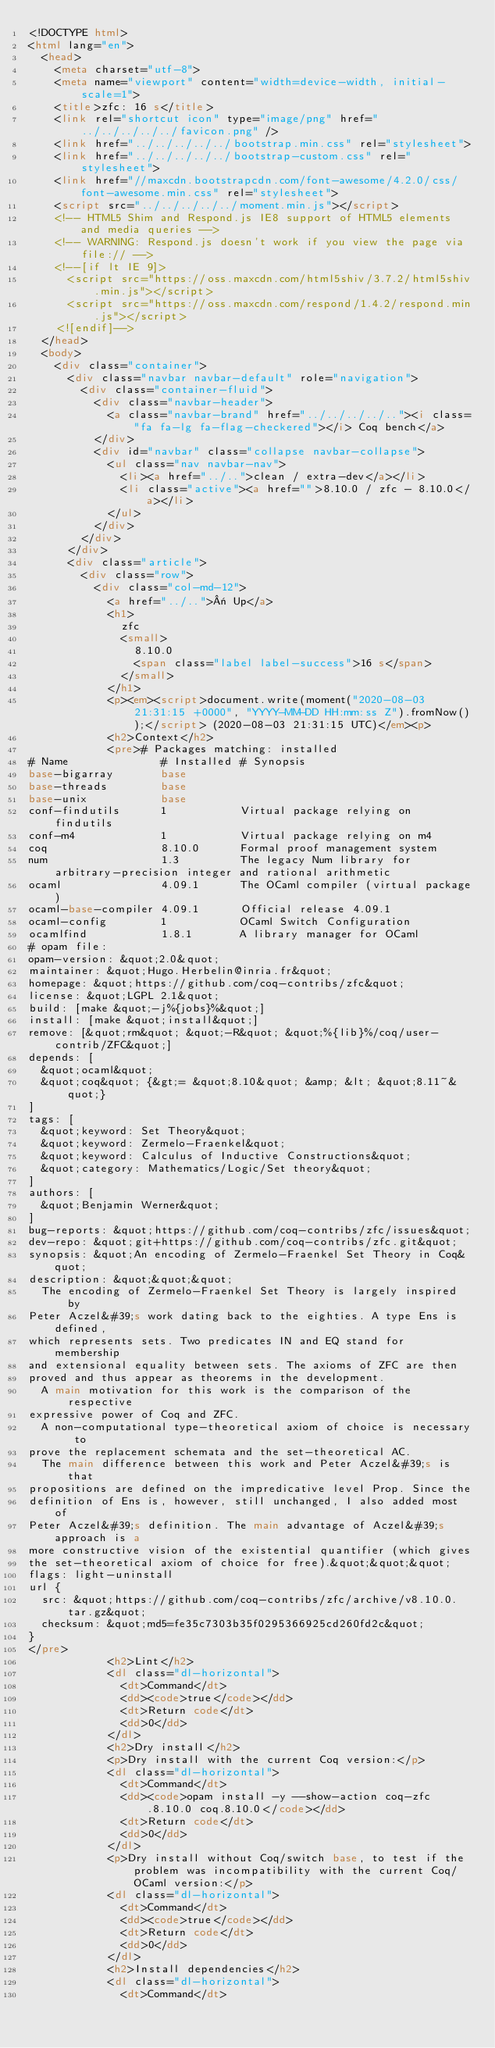Convert code to text. <code><loc_0><loc_0><loc_500><loc_500><_HTML_><!DOCTYPE html>
<html lang="en">
  <head>
    <meta charset="utf-8">
    <meta name="viewport" content="width=device-width, initial-scale=1">
    <title>zfc: 16 s</title>
    <link rel="shortcut icon" type="image/png" href="../../../../../favicon.png" />
    <link href="../../../../../bootstrap.min.css" rel="stylesheet">
    <link href="../../../../../bootstrap-custom.css" rel="stylesheet">
    <link href="//maxcdn.bootstrapcdn.com/font-awesome/4.2.0/css/font-awesome.min.css" rel="stylesheet">
    <script src="../../../../../moment.min.js"></script>
    <!-- HTML5 Shim and Respond.js IE8 support of HTML5 elements and media queries -->
    <!-- WARNING: Respond.js doesn't work if you view the page via file:// -->
    <!--[if lt IE 9]>
      <script src="https://oss.maxcdn.com/html5shiv/3.7.2/html5shiv.min.js"></script>
      <script src="https://oss.maxcdn.com/respond/1.4.2/respond.min.js"></script>
    <![endif]-->
  </head>
  <body>
    <div class="container">
      <div class="navbar navbar-default" role="navigation">
        <div class="container-fluid">
          <div class="navbar-header">
            <a class="navbar-brand" href="../../../../.."><i class="fa fa-lg fa-flag-checkered"></i> Coq bench</a>
          </div>
          <div id="navbar" class="collapse navbar-collapse">
            <ul class="nav navbar-nav">
              <li><a href="../..">clean / extra-dev</a></li>
              <li class="active"><a href="">8.10.0 / zfc - 8.10.0</a></li>
            </ul>
          </div>
        </div>
      </div>
      <div class="article">
        <div class="row">
          <div class="col-md-12">
            <a href="../..">« Up</a>
            <h1>
              zfc
              <small>
                8.10.0
                <span class="label label-success">16 s</span>
              </small>
            </h1>
            <p><em><script>document.write(moment("2020-08-03 21:31:15 +0000", "YYYY-MM-DD HH:mm:ss Z").fromNow());</script> (2020-08-03 21:31:15 UTC)</em><p>
            <h2>Context</h2>
            <pre># Packages matching: installed
# Name              # Installed # Synopsis
base-bigarray       base
base-threads        base
base-unix           base
conf-findutils      1           Virtual package relying on findutils
conf-m4             1           Virtual package relying on m4
coq                 8.10.0      Formal proof management system
num                 1.3         The legacy Num library for arbitrary-precision integer and rational arithmetic
ocaml               4.09.1      The OCaml compiler (virtual package)
ocaml-base-compiler 4.09.1      Official release 4.09.1
ocaml-config        1           OCaml Switch Configuration
ocamlfind           1.8.1       A library manager for OCaml
# opam file:
opam-version: &quot;2.0&quot;
maintainer: &quot;Hugo.Herbelin@inria.fr&quot;
homepage: &quot;https://github.com/coq-contribs/zfc&quot;
license: &quot;LGPL 2.1&quot;
build: [make &quot;-j%{jobs}%&quot;]
install: [make &quot;install&quot;]
remove: [&quot;rm&quot; &quot;-R&quot; &quot;%{lib}%/coq/user-contrib/ZFC&quot;]
depends: [
  &quot;ocaml&quot;
  &quot;coq&quot; {&gt;= &quot;8.10&quot; &amp; &lt; &quot;8.11~&quot;}
]
tags: [
  &quot;keyword: Set Theory&quot;
  &quot;keyword: Zermelo-Fraenkel&quot;
  &quot;keyword: Calculus of Inductive Constructions&quot;
  &quot;category: Mathematics/Logic/Set theory&quot;
]
authors: [
  &quot;Benjamin Werner&quot;
]
bug-reports: &quot;https://github.com/coq-contribs/zfc/issues&quot;
dev-repo: &quot;git+https://github.com/coq-contribs/zfc.git&quot;
synopsis: &quot;An encoding of Zermelo-Fraenkel Set Theory in Coq&quot;
description: &quot;&quot;&quot;
  The encoding of Zermelo-Fraenkel Set Theory is largely inspired by
Peter Aczel&#39;s work dating back to the eighties. A type Ens is defined,
which represents sets. Two predicates IN and EQ stand for membership
and extensional equality between sets. The axioms of ZFC are then
proved and thus appear as theorems in the development.
  A main motivation for this work is the comparison of the respective
expressive power of Coq and ZFC.
  A non-computational type-theoretical axiom of choice is necessary to
prove the replacement schemata and the set-theoretical AC.
  The main difference between this work and Peter Aczel&#39;s is that
propositions are defined on the impredicative level Prop. Since the
definition of Ens is, however, still unchanged, I also added most of
Peter Aczel&#39;s definition. The main advantage of Aczel&#39;s approach is a
more constructive vision of the existential quantifier (which gives
the set-theoretical axiom of choice for free).&quot;&quot;&quot;
flags: light-uninstall
url {
  src: &quot;https://github.com/coq-contribs/zfc/archive/v8.10.0.tar.gz&quot;
  checksum: &quot;md5=fe35c7303b35f0295366925cd260fd2c&quot;
}
</pre>
            <h2>Lint</h2>
            <dl class="dl-horizontal">
              <dt>Command</dt>
              <dd><code>true</code></dd>
              <dt>Return code</dt>
              <dd>0</dd>
            </dl>
            <h2>Dry install</h2>
            <p>Dry install with the current Coq version:</p>
            <dl class="dl-horizontal">
              <dt>Command</dt>
              <dd><code>opam install -y --show-action coq-zfc.8.10.0 coq.8.10.0</code></dd>
              <dt>Return code</dt>
              <dd>0</dd>
            </dl>
            <p>Dry install without Coq/switch base, to test if the problem was incompatibility with the current Coq/OCaml version:</p>
            <dl class="dl-horizontal">
              <dt>Command</dt>
              <dd><code>true</code></dd>
              <dt>Return code</dt>
              <dd>0</dd>
            </dl>
            <h2>Install dependencies</h2>
            <dl class="dl-horizontal">
              <dt>Command</dt></code> 